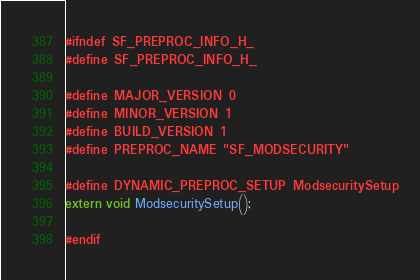<code> <loc_0><loc_0><loc_500><loc_500><_C_>#ifndef SF_PREPROC_INFO_H_
#define SF_PREPROC_INFO_H_

#define MAJOR_VERSION 0
#define MINOR_VERSION 1
#define BUILD_VERSION 1
#define PREPROC_NAME "SF_MODSECURITY"

#define DYNAMIC_PREPROC_SETUP ModsecuritySetup
extern void ModsecuritySetup();

#endif
</code> 